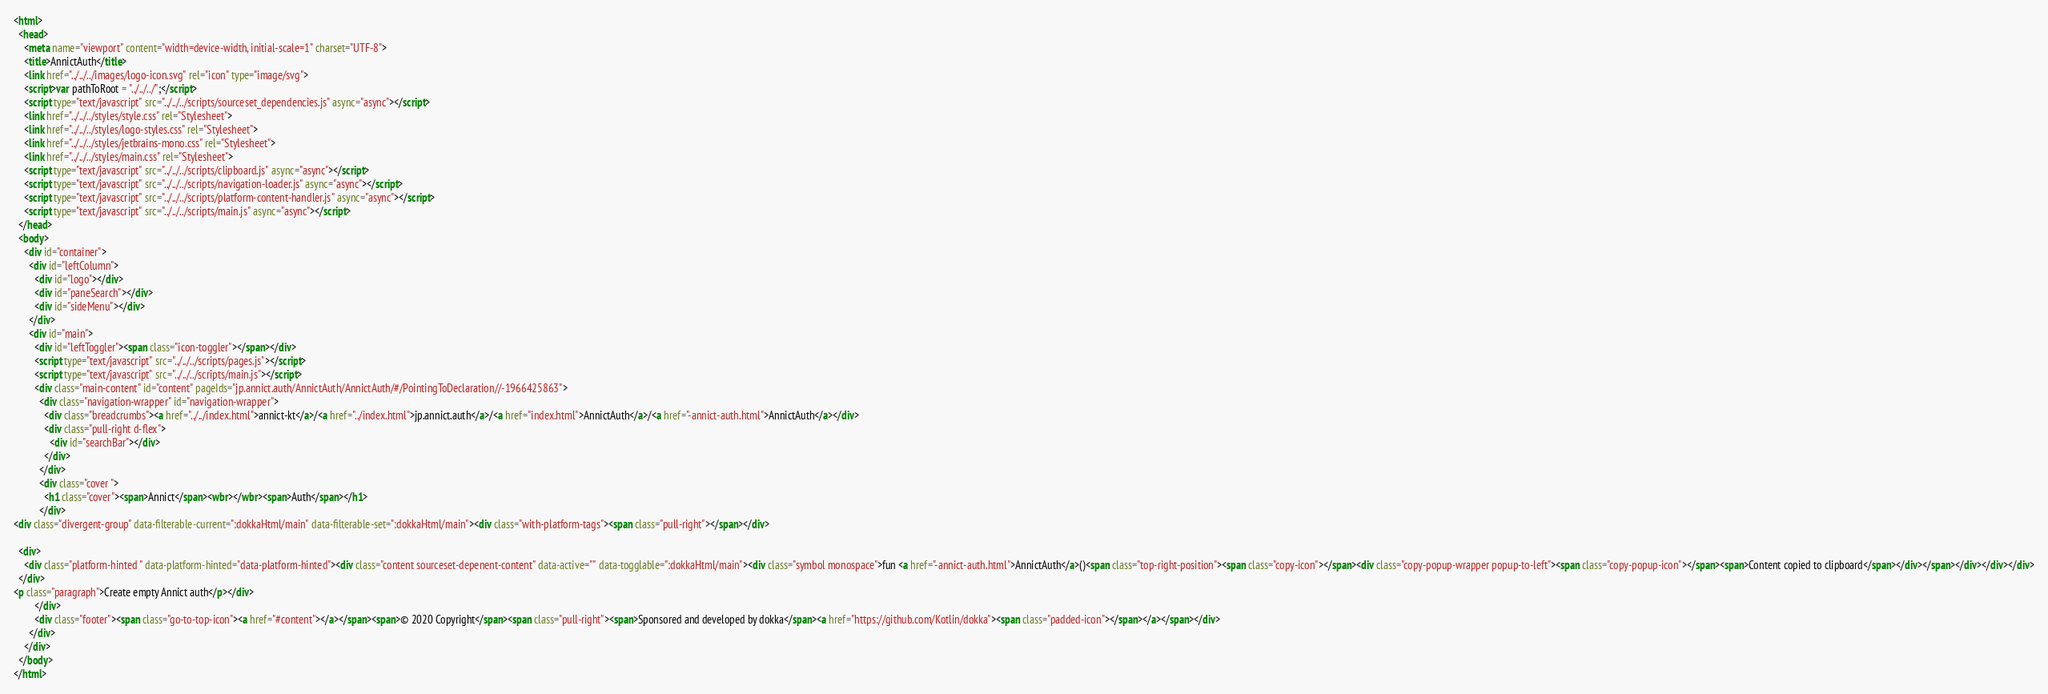<code> <loc_0><loc_0><loc_500><loc_500><_HTML_><html>
  <head>
    <meta name="viewport" content="width=device-width, initial-scale=1" charset="UTF-8">
    <title>AnnictAuth</title>
    <link href="../../../images/logo-icon.svg" rel="icon" type="image/svg">
    <script>var pathToRoot = "../../../";</script>
    <script type="text/javascript" src="../../../scripts/sourceset_dependencies.js" async="async"></script>
    <link href="../../../styles/style.css" rel="Stylesheet">
    <link href="../../../styles/logo-styles.css" rel="Stylesheet">
    <link href="../../../styles/jetbrains-mono.css" rel="Stylesheet">
    <link href="../../../styles/main.css" rel="Stylesheet">
    <script type="text/javascript" src="../../../scripts/clipboard.js" async="async"></script>
    <script type="text/javascript" src="../../../scripts/navigation-loader.js" async="async"></script>
    <script type="text/javascript" src="../../../scripts/platform-content-handler.js" async="async"></script>
    <script type="text/javascript" src="../../../scripts/main.js" async="async"></script>
  </head>
  <body>
    <div id="container">
      <div id="leftColumn">
        <div id="logo"></div>
        <div id="paneSearch"></div>
        <div id="sideMenu"></div>
      </div>
      <div id="main">
        <div id="leftToggler"><span class="icon-toggler"></span></div>
        <script type="text/javascript" src="../../../scripts/pages.js"></script>
        <script type="text/javascript" src="../../../scripts/main.js"></script>
        <div class="main-content" id="content" pageIds="jp.annict.auth/AnnictAuth/AnnictAuth/#/PointingToDeclaration//-1966425863">
          <div class="navigation-wrapper" id="navigation-wrapper">
            <div class="breadcrumbs"><a href="../../index.html">annict-kt</a>/<a href="../index.html">jp.annict.auth</a>/<a href="index.html">AnnictAuth</a>/<a href="-annict-auth.html">AnnictAuth</a></div>
            <div class="pull-right d-flex">
              <div id="searchBar"></div>
            </div>
          </div>
          <div class="cover ">
            <h1 class="cover"><span>Annict</span><wbr></wbr><span>Auth</span></h1>
          </div>
<div class="divergent-group" data-filterable-current=":dokkaHtml/main" data-filterable-set=":dokkaHtml/main"><div class="with-platform-tags"><span class="pull-right"></span></div>

  <div>
    <div class="platform-hinted " data-platform-hinted="data-platform-hinted"><div class="content sourceset-depenent-content" data-active="" data-togglable=":dokkaHtml/main"><div class="symbol monospace">fun <a href="-annict-auth.html">AnnictAuth</a>()<span class="top-right-position"><span class="copy-icon"></span><div class="copy-popup-wrapper popup-to-left"><span class="copy-popup-icon"></span><span>Content copied to clipboard</span></div></span></div></div></div>
  </div>
<p class="paragraph">Create empty Annict auth</p></div>
        </div>
        <div class="footer"><span class="go-to-top-icon"><a href="#content"></a></span><span>© 2020 Copyright</span><span class="pull-right"><span>Sponsored and developed by dokka</span><a href="https://github.com/Kotlin/dokka"><span class="padded-icon"></span></a></span></div>
      </div>
    </div>
  </body>
</html>

</code> 